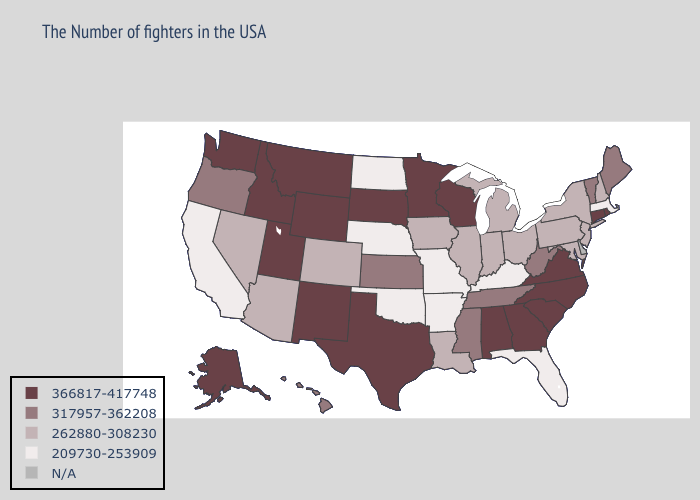Name the states that have a value in the range 366817-417748?
Short answer required. Rhode Island, Connecticut, Virginia, North Carolina, South Carolina, Georgia, Alabama, Wisconsin, Minnesota, Texas, South Dakota, Wyoming, New Mexico, Utah, Montana, Idaho, Washington, Alaska. Name the states that have a value in the range 366817-417748?
Be succinct. Rhode Island, Connecticut, Virginia, North Carolina, South Carolina, Georgia, Alabama, Wisconsin, Minnesota, Texas, South Dakota, Wyoming, New Mexico, Utah, Montana, Idaho, Washington, Alaska. Does Oregon have the lowest value in the West?
Give a very brief answer. No. Name the states that have a value in the range 262880-308230?
Concise answer only. New Hampshire, New York, New Jersey, Maryland, Pennsylvania, Ohio, Michigan, Indiana, Illinois, Louisiana, Iowa, Colorado, Arizona, Nevada. Among the states that border Delaware , which have the lowest value?
Give a very brief answer. New Jersey, Maryland, Pennsylvania. Does South Dakota have the lowest value in the MidWest?
Short answer required. No. Which states have the lowest value in the South?
Concise answer only. Florida, Kentucky, Arkansas, Oklahoma. Which states hav the highest value in the South?
Give a very brief answer. Virginia, North Carolina, South Carolina, Georgia, Alabama, Texas. Name the states that have a value in the range 209730-253909?
Be succinct. Massachusetts, Florida, Kentucky, Missouri, Arkansas, Nebraska, Oklahoma, North Dakota, California. Name the states that have a value in the range 317957-362208?
Give a very brief answer. Maine, Vermont, West Virginia, Tennessee, Mississippi, Kansas, Oregon, Hawaii. What is the value of Michigan?
Short answer required. 262880-308230. Which states hav the highest value in the MidWest?
Write a very short answer. Wisconsin, Minnesota, South Dakota. Which states have the highest value in the USA?
Concise answer only. Rhode Island, Connecticut, Virginia, North Carolina, South Carolina, Georgia, Alabama, Wisconsin, Minnesota, Texas, South Dakota, Wyoming, New Mexico, Utah, Montana, Idaho, Washington, Alaska. 